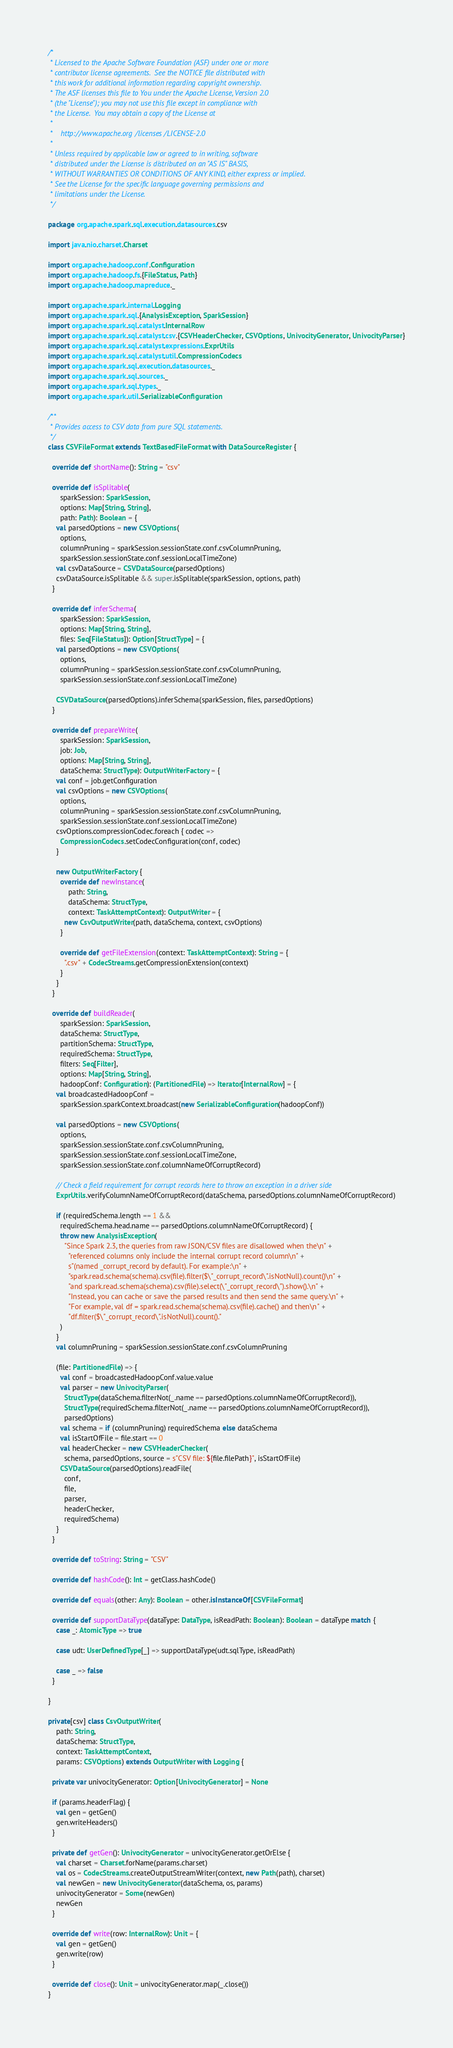Convert code to text. <code><loc_0><loc_0><loc_500><loc_500><_Scala_>/*
 * Licensed to the Apache Software Foundation (ASF) under one or more
 * contributor license agreements.  See the NOTICE file distributed with
 * this work for additional information regarding copyright ownership.
 * The ASF licenses this file to You under the Apache License, Version 2.0
 * (the "License"); you may not use this file except in compliance with
 * the License.  You may obtain a copy of the License at
 *
 *    http://www.apache.org/licenses/LICENSE-2.0
 *
 * Unless required by applicable law or agreed to in writing, software
 * distributed under the License is distributed on an "AS IS" BASIS,
 * WITHOUT WARRANTIES OR CONDITIONS OF ANY KIND, either express or implied.
 * See the License for the specific language governing permissions and
 * limitations under the License.
 */

package org.apache.spark.sql.execution.datasources.csv

import java.nio.charset.Charset

import org.apache.hadoop.conf.Configuration
import org.apache.hadoop.fs.{FileStatus, Path}
import org.apache.hadoop.mapreduce._

import org.apache.spark.internal.Logging
import org.apache.spark.sql.{AnalysisException, SparkSession}
import org.apache.spark.sql.catalyst.InternalRow
import org.apache.spark.sql.catalyst.csv.{CSVHeaderChecker, CSVOptions, UnivocityGenerator, UnivocityParser}
import org.apache.spark.sql.catalyst.expressions.ExprUtils
import org.apache.spark.sql.catalyst.util.CompressionCodecs
import org.apache.spark.sql.execution.datasources._
import org.apache.spark.sql.sources._
import org.apache.spark.sql.types._
import org.apache.spark.util.SerializableConfiguration

/**
 * Provides access to CSV data from pure SQL statements.
 */
class CSVFileFormat extends TextBasedFileFormat with DataSourceRegister {

  override def shortName(): String = "csv"

  override def isSplitable(
      sparkSession: SparkSession,
      options: Map[String, String],
      path: Path): Boolean = {
    val parsedOptions = new CSVOptions(
      options,
      columnPruning = sparkSession.sessionState.conf.csvColumnPruning,
      sparkSession.sessionState.conf.sessionLocalTimeZone)
    val csvDataSource = CSVDataSource(parsedOptions)
    csvDataSource.isSplitable && super.isSplitable(sparkSession, options, path)
  }

  override def inferSchema(
      sparkSession: SparkSession,
      options: Map[String, String],
      files: Seq[FileStatus]): Option[StructType] = {
    val parsedOptions = new CSVOptions(
      options,
      columnPruning = sparkSession.sessionState.conf.csvColumnPruning,
      sparkSession.sessionState.conf.sessionLocalTimeZone)

    CSVDataSource(parsedOptions).inferSchema(sparkSession, files, parsedOptions)
  }

  override def prepareWrite(
      sparkSession: SparkSession,
      job: Job,
      options: Map[String, String],
      dataSchema: StructType): OutputWriterFactory = {
    val conf = job.getConfiguration
    val csvOptions = new CSVOptions(
      options,
      columnPruning = sparkSession.sessionState.conf.csvColumnPruning,
      sparkSession.sessionState.conf.sessionLocalTimeZone)
    csvOptions.compressionCodec.foreach { codec =>
      CompressionCodecs.setCodecConfiguration(conf, codec)
    }

    new OutputWriterFactory {
      override def newInstance(
          path: String,
          dataSchema: StructType,
          context: TaskAttemptContext): OutputWriter = {
        new CsvOutputWriter(path, dataSchema, context, csvOptions)
      }

      override def getFileExtension(context: TaskAttemptContext): String = {
        ".csv" + CodecStreams.getCompressionExtension(context)
      }
    }
  }

  override def buildReader(
      sparkSession: SparkSession,
      dataSchema: StructType,
      partitionSchema: StructType,
      requiredSchema: StructType,
      filters: Seq[Filter],
      options: Map[String, String],
      hadoopConf: Configuration): (PartitionedFile) => Iterator[InternalRow] = {
    val broadcastedHadoopConf =
      sparkSession.sparkContext.broadcast(new SerializableConfiguration(hadoopConf))

    val parsedOptions = new CSVOptions(
      options,
      sparkSession.sessionState.conf.csvColumnPruning,
      sparkSession.sessionState.conf.sessionLocalTimeZone,
      sparkSession.sessionState.conf.columnNameOfCorruptRecord)

    // Check a field requirement for corrupt records here to throw an exception in a driver side
    ExprUtils.verifyColumnNameOfCorruptRecord(dataSchema, parsedOptions.columnNameOfCorruptRecord)

    if (requiredSchema.length == 1 &&
      requiredSchema.head.name == parsedOptions.columnNameOfCorruptRecord) {
      throw new AnalysisException(
        "Since Spark 2.3, the queries from raw JSON/CSV files are disallowed when the\n" +
          "referenced columns only include the internal corrupt record column\n" +
          s"(named _corrupt_record by default). For example:\n" +
          "spark.read.schema(schema).csv(file).filter($\"_corrupt_record\".isNotNull).count()\n" +
          "and spark.read.schema(schema).csv(file).select(\"_corrupt_record\").show().\n" +
          "Instead, you can cache or save the parsed results and then send the same query.\n" +
          "For example, val df = spark.read.schema(schema).csv(file).cache() and then\n" +
          "df.filter($\"_corrupt_record\".isNotNull).count()."
      )
    }
    val columnPruning = sparkSession.sessionState.conf.csvColumnPruning

    (file: PartitionedFile) => {
      val conf = broadcastedHadoopConf.value.value
      val parser = new UnivocityParser(
        StructType(dataSchema.filterNot(_.name == parsedOptions.columnNameOfCorruptRecord)),
        StructType(requiredSchema.filterNot(_.name == parsedOptions.columnNameOfCorruptRecord)),
        parsedOptions)
      val schema = if (columnPruning) requiredSchema else dataSchema
      val isStartOfFile = file.start == 0
      val headerChecker = new CSVHeaderChecker(
        schema, parsedOptions, source = s"CSV file: ${file.filePath}", isStartOfFile)
      CSVDataSource(parsedOptions).readFile(
        conf,
        file,
        parser,
        headerChecker,
        requiredSchema)
    }
  }

  override def toString: String = "CSV"

  override def hashCode(): Int = getClass.hashCode()

  override def equals(other: Any): Boolean = other.isInstanceOf[CSVFileFormat]

  override def supportDataType(dataType: DataType, isReadPath: Boolean): Boolean = dataType match {
    case _: AtomicType => true

    case udt: UserDefinedType[_] => supportDataType(udt.sqlType, isReadPath)

    case _ => false
  }

}

private[csv] class CsvOutputWriter(
    path: String,
    dataSchema: StructType,
    context: TaskAttemptContext,
    params: CSVOptions) extends OutputWriter with Logging {

  private var univocityGenerator: Option[UnivocityGenerator] = None

  if (params.headerFlag) {
    val gen = getGen()
    gen.writeHeaders()
  }

  private def getGen(): UnivocityGenerator = univocityGenerator.getOrElse {
    val charset = Charset.forName(params.charset)
    val os = CodecStreams.createOutputStreamWriter(context, new Path(path), charset)
    val newGen = new UnivocityGenerator(dataSchema, os, params)
    univocityGenerator = Some(newGen)
    newGen
  }

  override def write(row: InternalRow): Unit = {
    val gen = getGen()
    gen.write(row)
  }

  override def close(): Unit = univocityGenerator.map(_.close())
}
</code> 